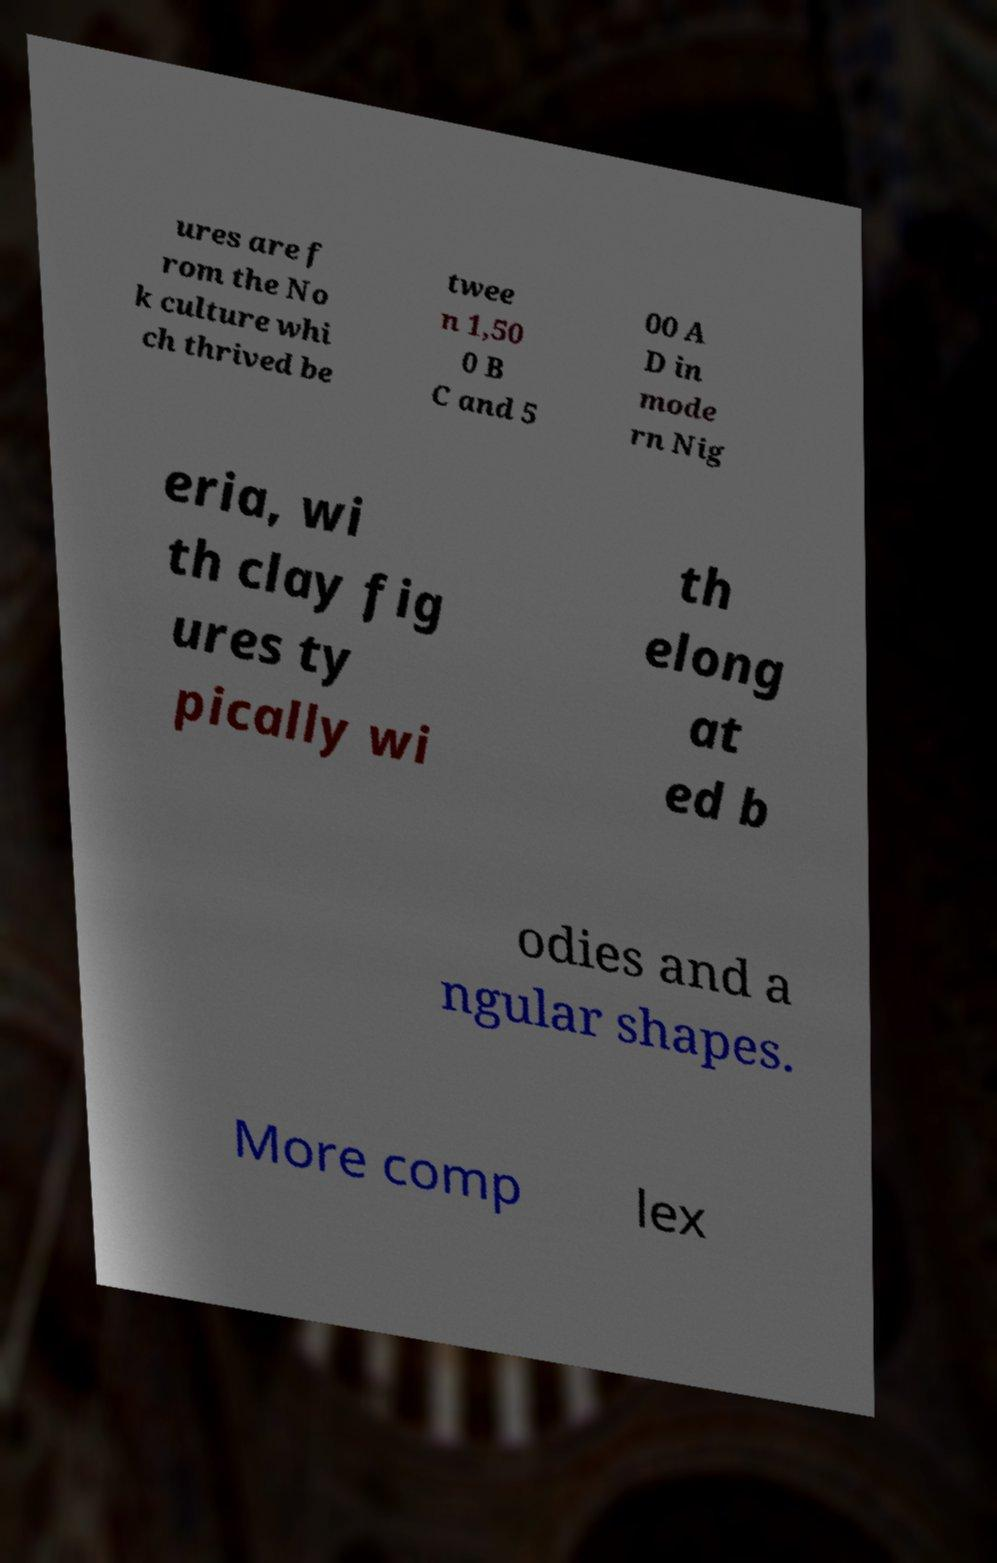Could you extract and type out the text from this image? ures are f rom the No k culture whi ch thrived be twee n 1,50 0 B C and 5 00 A D in mode rn Nig eria, wi th clay fig ures ty pically wi th elong at ed b odies and a ngular shapes. More comp lex 